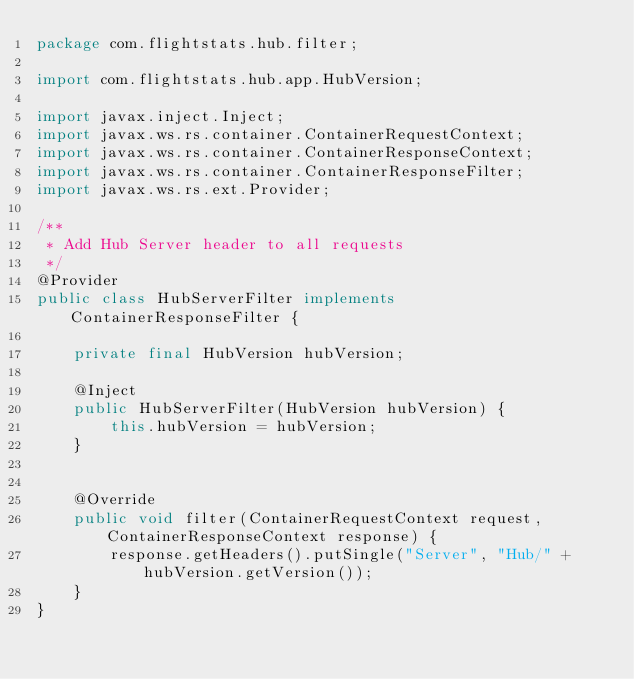<code> <loc_0><loc_0><loc_500><loc_500><_Java_>package com.flightstats.hub.filter;

import com.flightstats.hub.app.HubVersion;

import javax.inject.Inject;
import javax.ws.rs.container.ContainerRequestContext;
import javax.ws.rs.container.ContainerResponseContext;
import javax.ws.rs.container.ContainerResponseFilter;
import javax.ws.rs.ext.Provider;

/**
 * Add Hub Server header to all requests
 */
@Provider
public class HubServerFilter implements ContainerResponseFilter {

    private final HubVersion hubVersion;

    @Inject
    public HubServerFilter(HubVersion hubVersion) {
        this.hubVersion = hubVersion;
    }


    @Override
    public void filter(ContainerRequestContext request, ContainerResponseContext response) {
        response.getHeaders().putSingle("Server", "Hub/" + hubVersion.getVersion());
    }
}</code> 